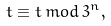<formula> <loc_0><loc_0><loc_500><loc_500>t \equiv t \, m o d \, 3 ^ { n } ,</formula> 